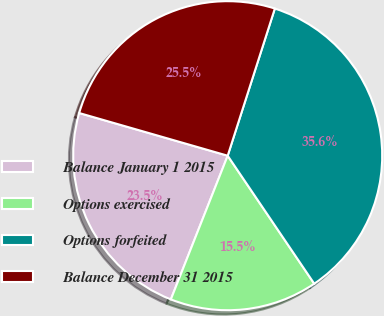Convert chart. <chart><loc_0><loc_0><loc_500><loc_500><pie_chart><fcel>Balance January 1 2015<fcel>Options exercised<fcel>Options forfeited<fcel>Balance December 31 2015<nl><fcel>23.46%<fcel>15.46%<fcel>35.6%<fcel>25.48%<nl></chart> 